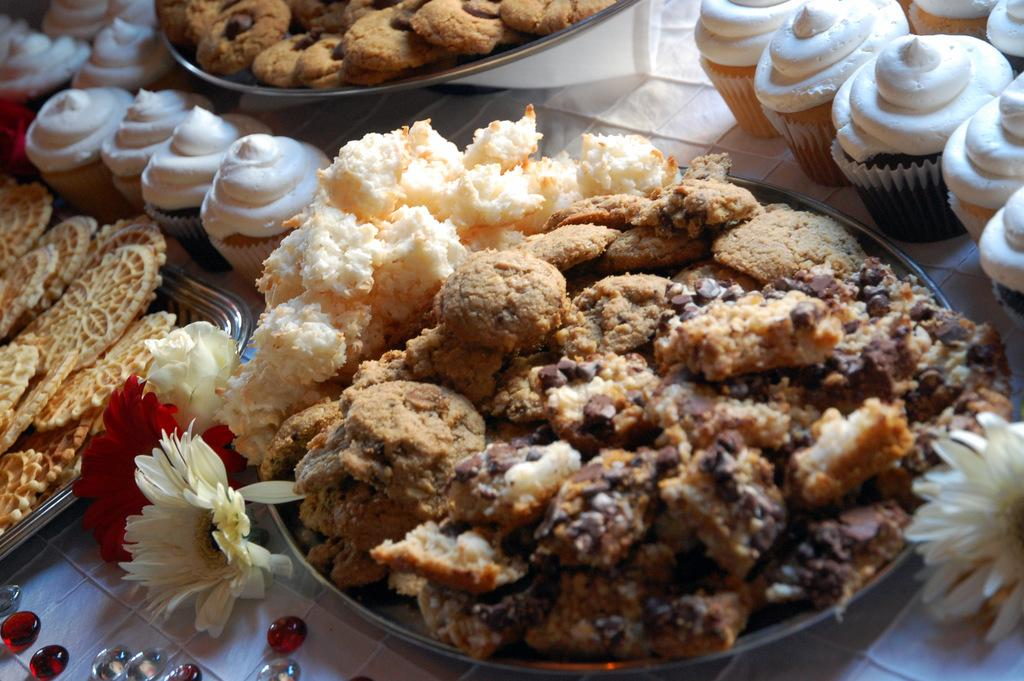What objects are present in the image that are used for serving food? There are plates in the image that are used for serving food. What types of food can be seen on the plates? The plates contain various food items, including cupcakes. What other decorative items are present in the image? There are flowers and beads in the image. On what surface are all these items placed? All these items are placed on a surface. What type of vegetable is being used as a veil in the image? There is no vegetable being used as a veil in the image, as the provided facts do not mention any such item. 